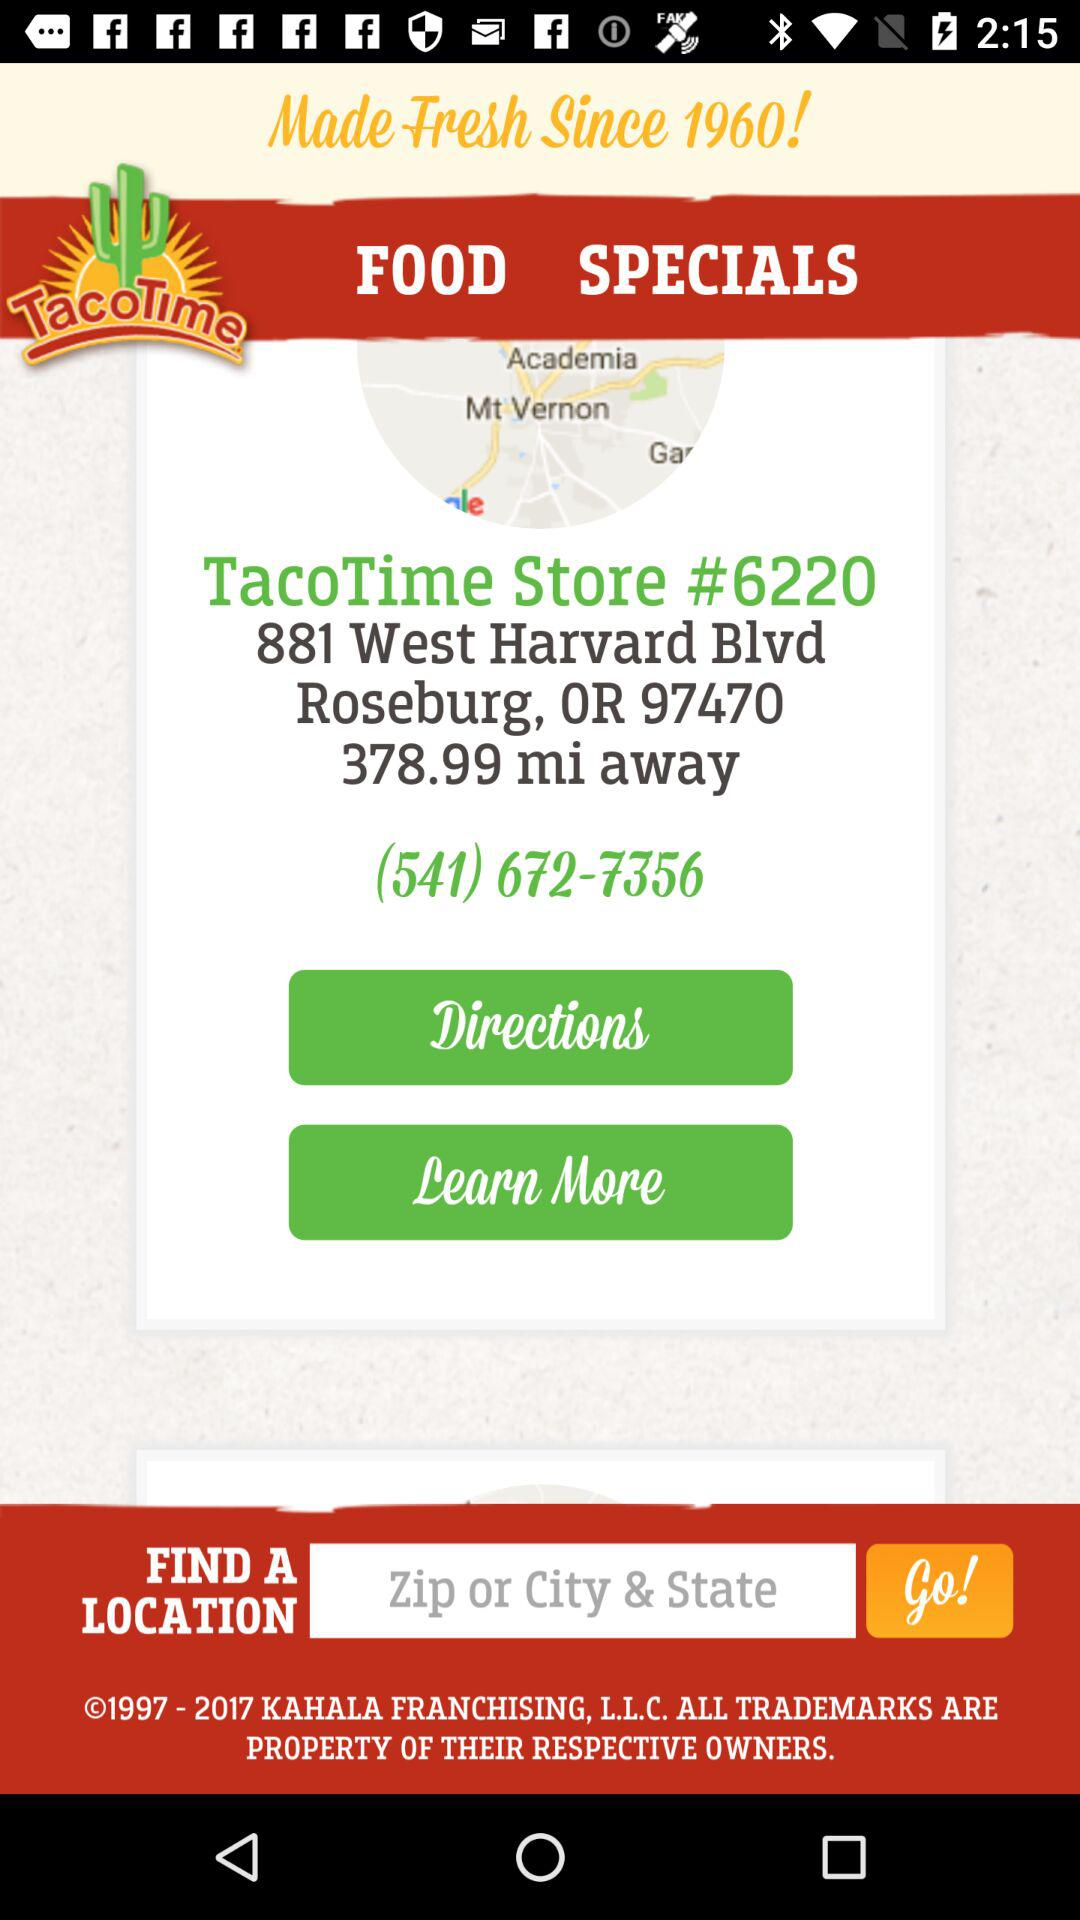What is the contact number? The contact number is (541) 672-7356. 